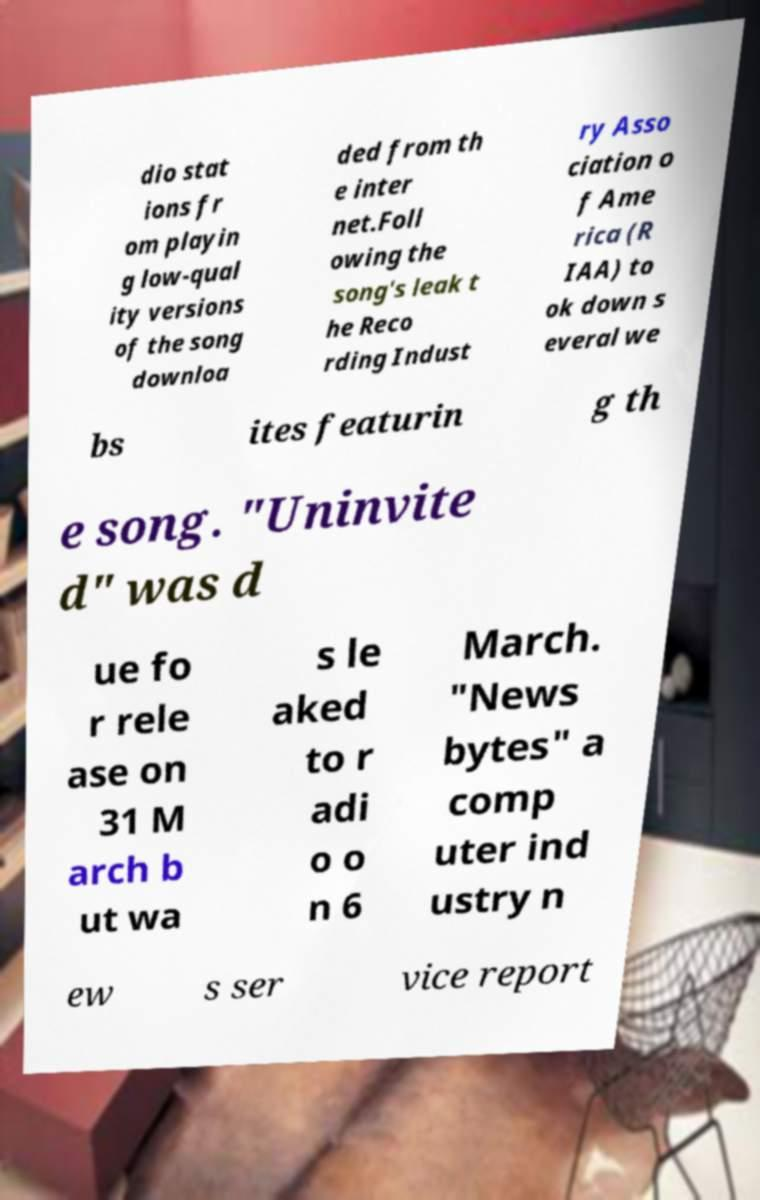Could you extract and type out the text from this image? dio stat ions fr om playin g low-qual ity versions of the song downloa ded from th e inter net.Foll owing the song's leak t he Reco rding Indust ry Asso ciation o f Ame rica (R IAA) to ok down s everal we bs ites featurin g th e song. "Uninvite d" was d ue fo r rele ase on 31 M arch b ut wa s le aked to r adi o o n 6 March. "News bytes" a comp uter ind ustry n ew s ser vice report 